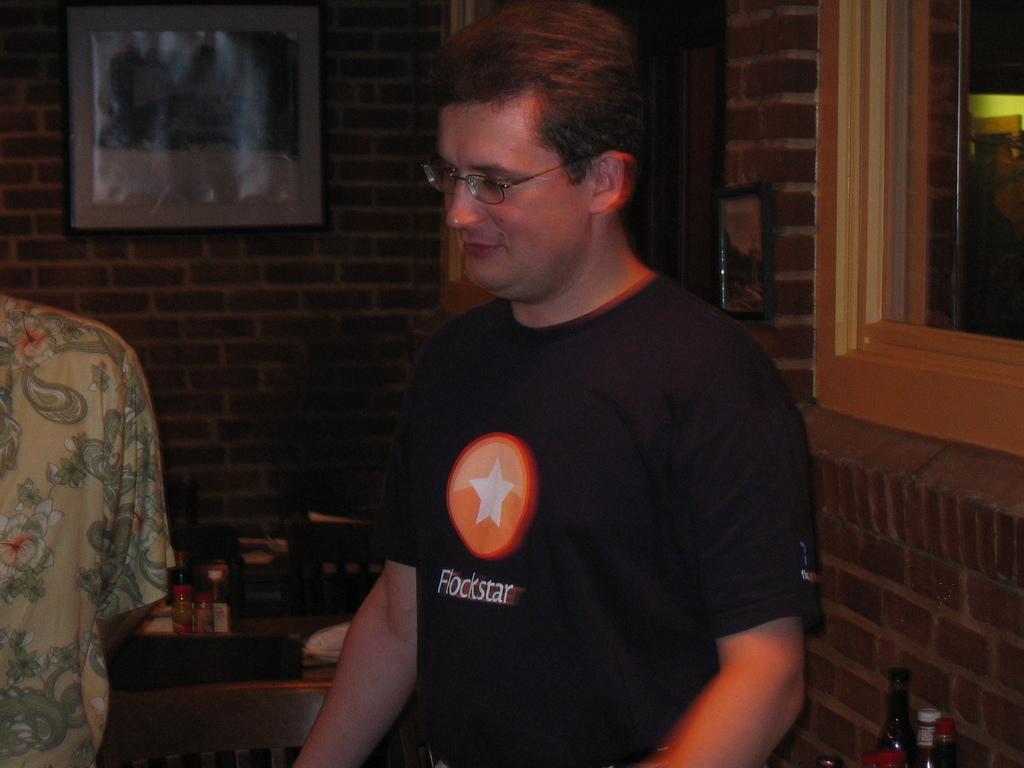Can you describe this image briefly? In this image we can see this person wearing black color T-shirt is having a logo on it and wearing spectacles is standing here. Here we can see another person. The background of the image is dark, where we can see bottles and a few more objects are kept on the table, we can see the photo frames on the brick wall and the glass windows here. 